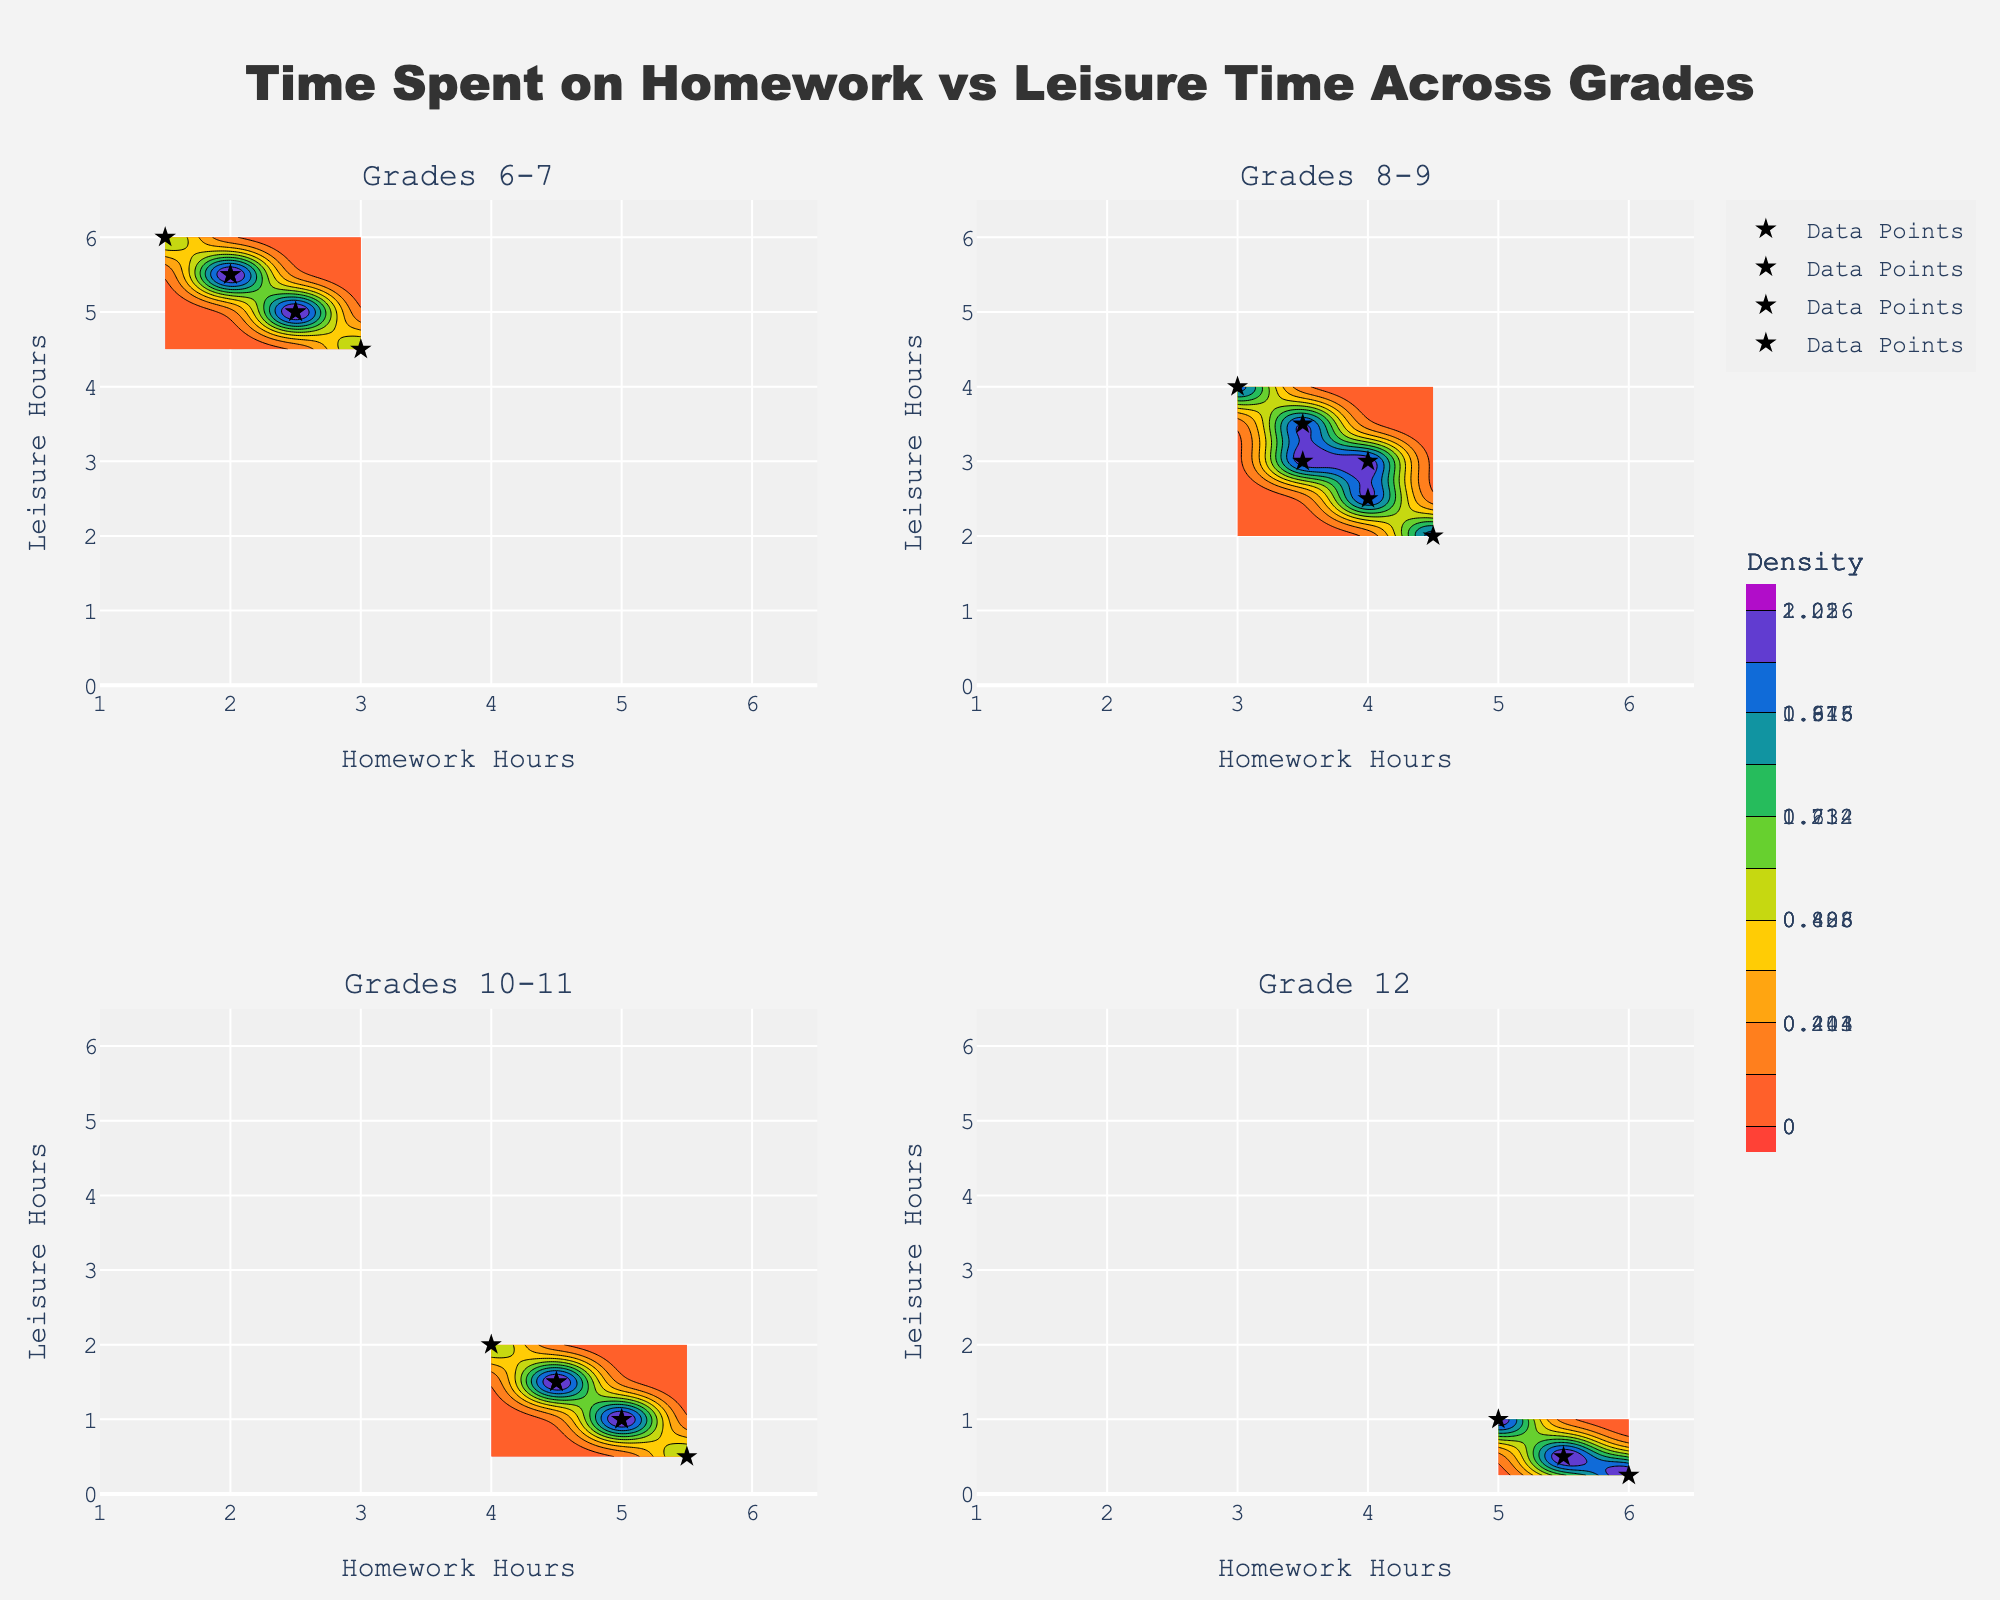Which subplot has the highest density of data points for homework hours around 5 hours? The subplot grades can be identified by their title. By checking the areas with high density around 5 hours of homework, the Grades 10-11 and Grade 12 subplots show higher density zones. So, the subplot with Grade 12 has the highest density.
Answer: Grade 12 What is the range of leisure hours for Grades 8-9? By looking at the axes of the 8-9 grade subplot, the leisure hours range from approximately 2.5 to 4.
Answer: 2.5 to 4 Which grade group shows the steepest decline in available leisure hours as homework hours increase? By comparing the subplots, the Grade 12 subplot shows the steepest decline in leisure hours when homework hours increase, evident from the tight contour lines.
Answer: Grade 12 Are there any grades where students have more than 5 hours of leisure time available? By checking each subplot for leisure hours greater than 5, the Grades 6-7 subplot shows areas where leisure time exceeds 5 hours.
Answer: Yes, Grades 6-7 Which subplot has the smallest maximum leisure hours? By looking at the y-axes, Grade 12 subplot shows a maximum leisure time of around 0.25 hours. This is the smallest compared to the other subplots.
Answer: Grade 12 How does leisure time vary within Grades 6-7 for students with 2.5 hours of homework? By looking at the Grades 6-7 subplot, for 2.5 hours of homework, leisure can range from about 5 to 6 hours as indicated by the spread in the data points and contour lines.
Answer: 5 to 6 hours Compare the leisure hours between Grades 8-9 and Grades 10-11 for students doing around 4 hours of homework. Which group has lower leisure time? By examining the 4-hour homework point in both subplots, Grades 10-11 have lower leisure hours (around 1 hour) compared to Grades 8-9 (about 2.5 hours).
Answer: Grades 10-11 In which grade group does increasing homework hours from 2 to 4 result in the most significant decrease in leisure time? By analyzing the slopes in each subplot, Grades 10-11 show the most significant decrease in leisure time from around 4.5 hours to approximately 1.5 hours.
Answer: Grades 10-11 How many subplots display hours dedicated to homework beyond 5 hours? By examining the homework hours across subplots, only the Grade 12 subplot displays homework hours beyond 5 hours.
Answer: 1 